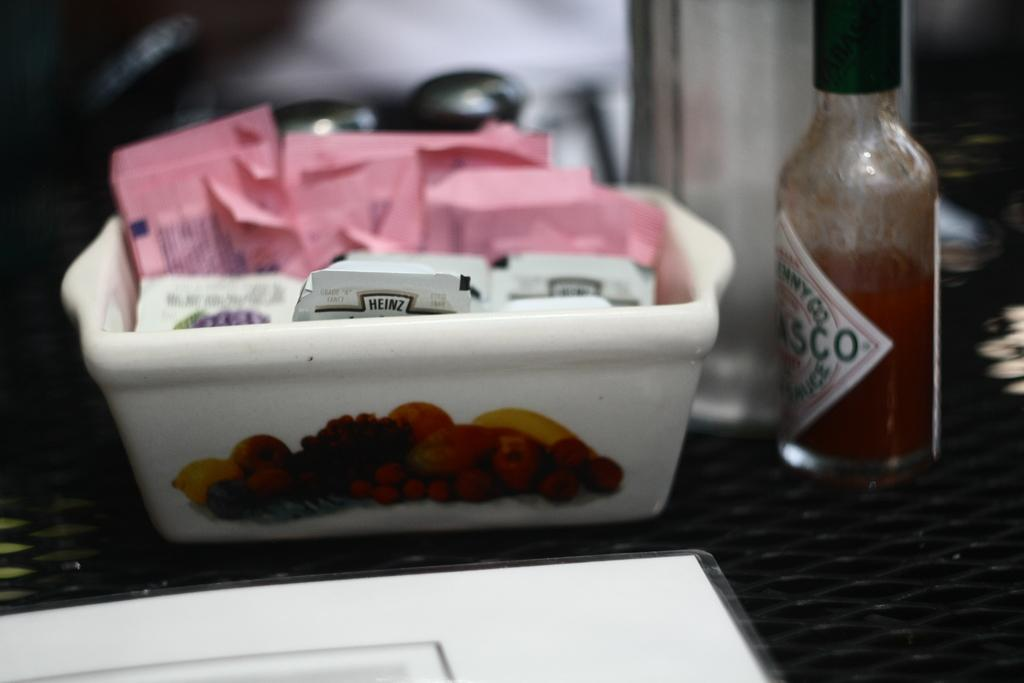<image>
Describe the image concisely. Bottle of tobasco sauce next to a box with other condiments. 